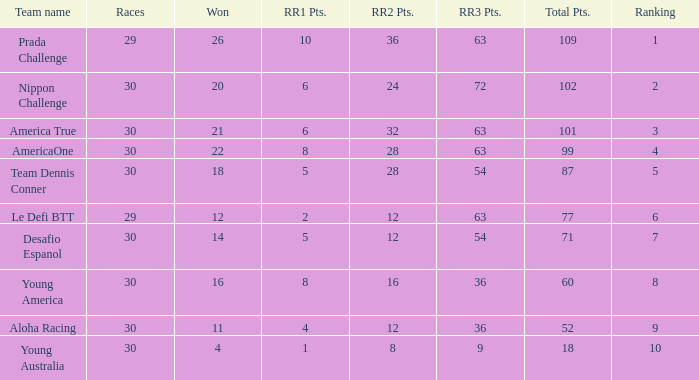Can you provide the ranking position for rr2 when it has 8 points? 10.0. 